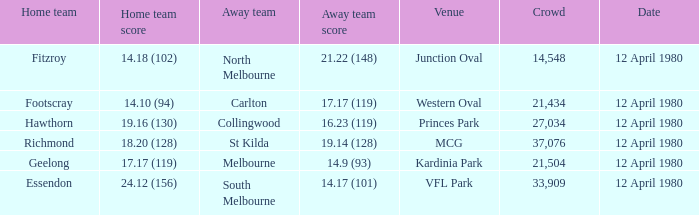Where did Essendon play as the home team? VFL Park. 